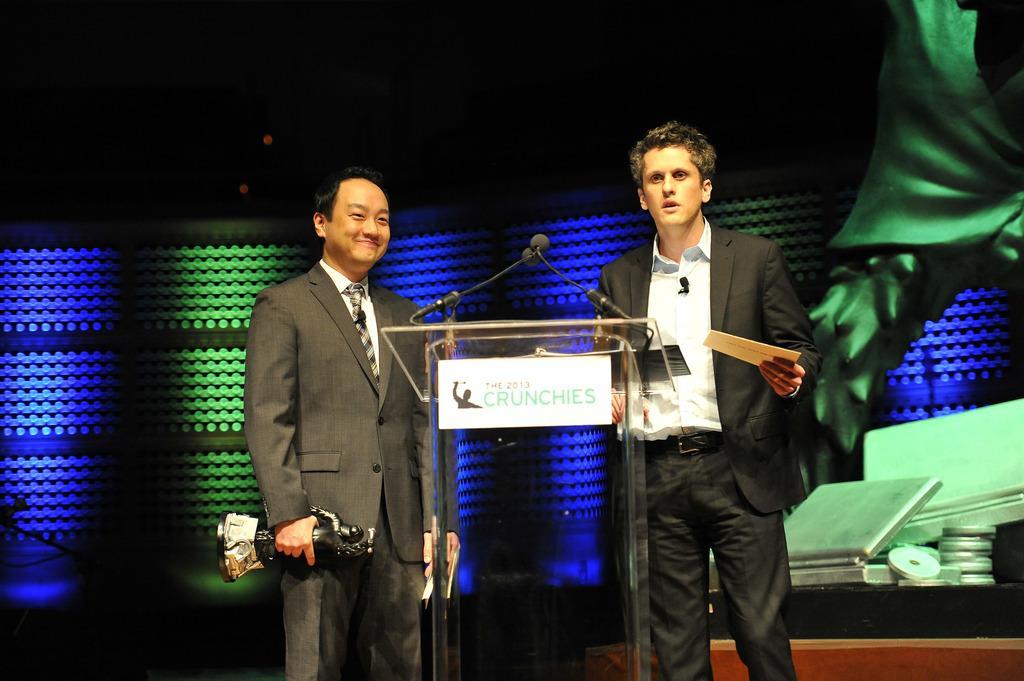Could you give a brief overview of what you see in this image? In the center of the image we can see a podium with the miles. We can also see a man standing and smiling and also holding an award. There is also a man holding the paper and standing. In the background we can see the design wall, lights and we can see some objects on the right. 